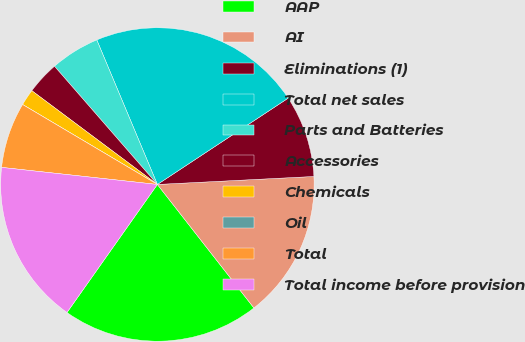<chart> <loc_0><loc_0><loc_500><loc_500><pie_chart><fcel>AAP<fcel>AI<fcel>Eliminations (1)<fcel>Total net sales<fcel>Parts and Batteries<fcel>Accessories<fcel>Chemicals<fcel>Oil<fcel>Total<fcel>Total income before provision<nl><fcel>20.34%<fcel>15.25%<fcel>8.47%<fcel>22.03%<fcel>5.08%<fcel>3.39%<fcel>1.69%<fcel>0.0%<fcel>6.78%<fcel>16.95%<nl></chart> 